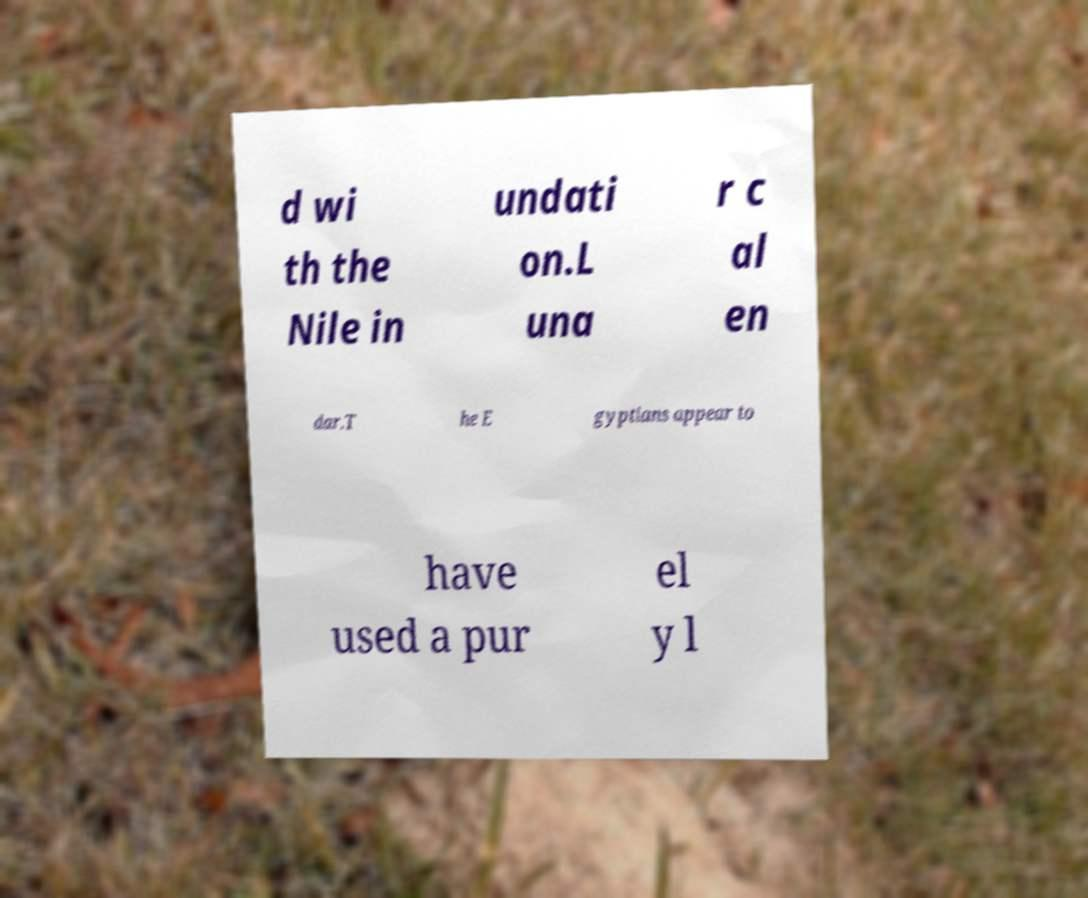I need the written content from this picture converted into text. Can you do that? d wi th the Nile in undati on.L una r c al en dar.T he E gyptians appear to have used a pur el y l 